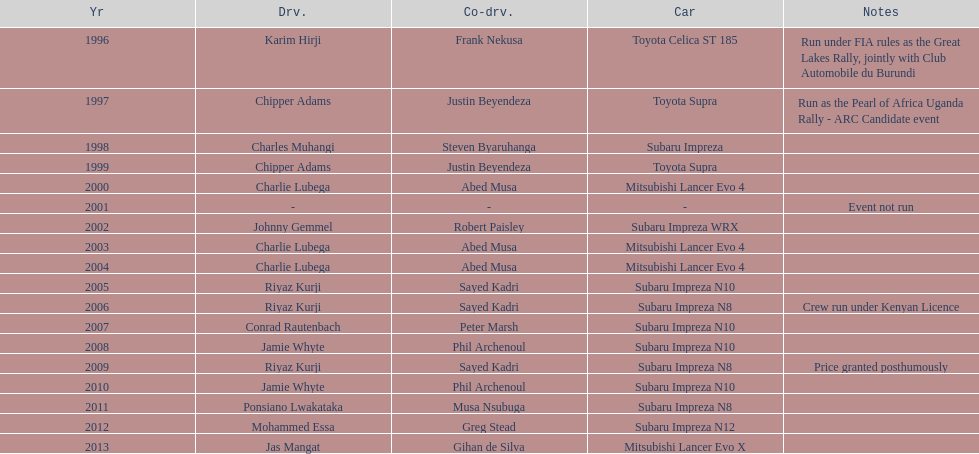Which driver won after ponsiano lwakataka? Mohammed Essa. Can you give me this table as a dict? {'header': ['Yr', 'Drv.', 'Co-drv.', 'Car', 'Notes'], 'rows': [['1996', 'Karim Hirji', 'Frank Nekusa', 'Toyota Celica ST 185', 'Run under FIA rules as the Great Lakes Rally, jointly with Club Automobile du Burundi'], ['1997', 'Chipper Adams', 'Justin Beyendeza', 'Toyota Supra', 'Run as the Pearl of Africa Uganda Rally - ARC Candidate event'], ['1998', 'Charles Muhangi', 'Steven Byaruhanga', 'Subaru Impreza', ''], ['1999', 'Chipper Adams', 'Justin Beyendeza', 'Toyota Supra', ''], ['2000', 'Charlie Lubega', 'Abed Musa', 'Mitsubishi Lancer Evo 4', ''], ['2001', '-', '-', '-', 'Event not run'], ['2002', 'Johnny Gemmel', 'Robert Paisley', 'Subaru Impreza WRX', ''], ['2003', 'Charlie Lubega', 'Abed Musa', 'Mitsubishi Lancer Evo 4', ''], ['2004', 'Charlie Lubega', 'Abed Musa', 'Mitsubishi Lancer Evo 4', ''], ['2005', 'Riyaz Kurji', 'Sayed Kadri', 'Subaru Impreza N10', ''], ['2006', 'Riyaz Kurji', 'Sayed Kadri', 'Subaru Impreza N8', 'Crew run under Kenyan Licence'], ['2007', 'Conrad Rautenbach', 'Peter Marsh', 'Subaru Impreza N10', ''], ['2008', 'Jamie Whyte', 'Phil Archenoul', 'Subaru Impreza N10', ''], ['2009', 'Riyaz Kurji', 'Sayed Kadri', 'Subaru Impreza N8', 'Price granted posthumously'], ['2010', 'Jamie Whyte', 'Phil Archenoul', 'Subaru Impreza N10', ''], ['2011', 'Ponsiano Lwakataka', 'Musa Nsubuga', 'Subaru Impreza N8', ''], ['2012', 'Mohammed Essa', 'Greg Stead', 'Subaru Impreza N12', ''], ['2013', 'Jas Mangat', 'Gihan de Silva', 'Mitsubishi Lancer Evo X', '']]} 